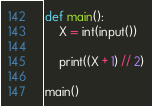<code> <loc_0><loc_0><loc_500><loc_500><_Python_>def main():
    X = int(input())

    print((X + 1) // 2)

main()
</code> 